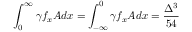<formula> <loc_0><loc_0><loc_500><loc_500>\int _ { 0 } ^ { \infty } \gamma f _ { x } A d x = \int _ { - \infty } ^ { 0 } \gamma f _ { x } A d x = \frac { \Delta ^ { 3 } } { 5 4 }</formula> 